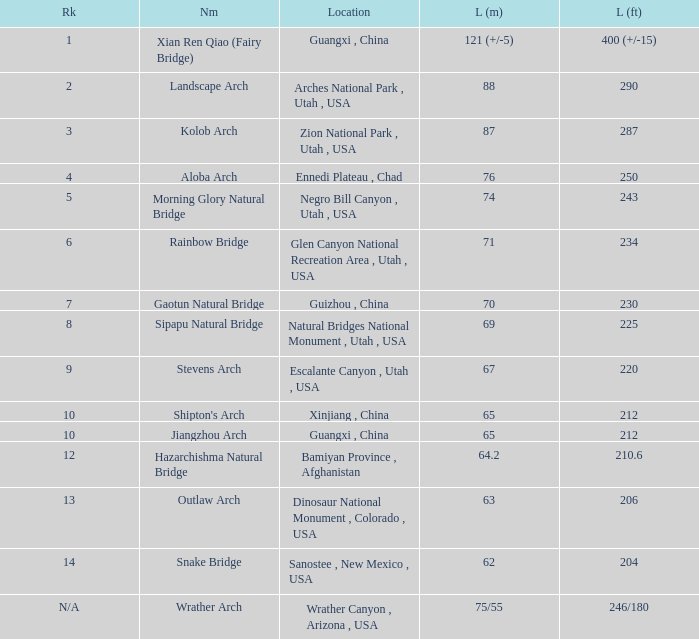How many feet long is the jiangzhou arch? 212.0. 